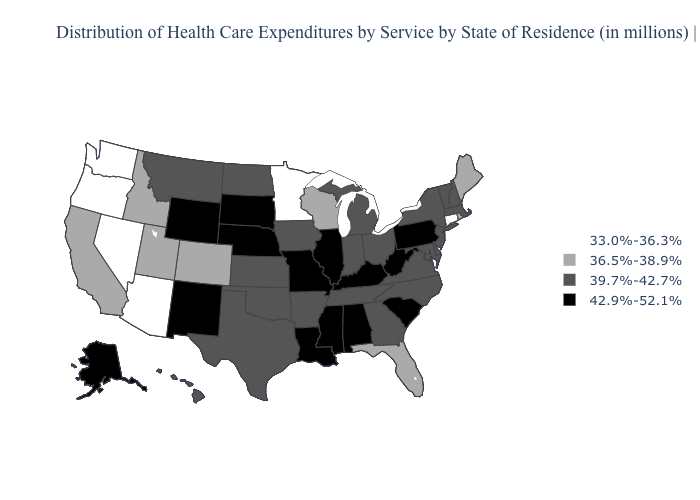What is the value of Kansas?
Answer briefly. 39.7%-42.7%. What is the value of Montana?
Concise answer only. 39.7%-42.7%. Name the states that have a value in the range 39.7%-42.7%?
Quick response, please. Arkansas, Delaware, Georgia, Hawaii, Indiana, Iowa, Kansas, Maryland, Massachusetts, Michigan, Montana, New Hampshire, New Jersey, New York, North Carolina, North Dakota, Ohio, Oklahoma, Tennessee, Texas, Vermont, Virginia. Does Oregon have a lower value than New Mexico?
Answer briefly. Yes. Which states have the lowest value in the South?
Concise answer only. Florida. Does the first symbol in the legend represent the smallest category?
Keep it brief. Yes. What is the lowest value in states that border Georgia?
Quick response, please. 36.5%-38.9%. Name the states that have a value in the range 33.0%-36.3%?
Give a very brief answer. Arizona, Connecticut, Minnesota, Nevada, Oregon, Washington. What is the value of Michigan?
Keep it brief. 39.7%-42.7%. Does Illinois have the highest value in the USA?
Short answer required. Yes. What is the value of Arizona?
Write a very short answer. 33.0%-36.3%. Is the legend a continuous bar?
Give a very brief answer. No. What is the lowest value in states that border Montana?
Write a very short answer. 36.5%-38.9%. Does Michigan have a lower value than Oklahoma?
Keep it brief. No. Name the states that have a value in the range 36.5%-38.9%?
Be succinct. California, Colorado, Florida, Idaho, Maine, Rhode Island, Utah, Wisconsin. 